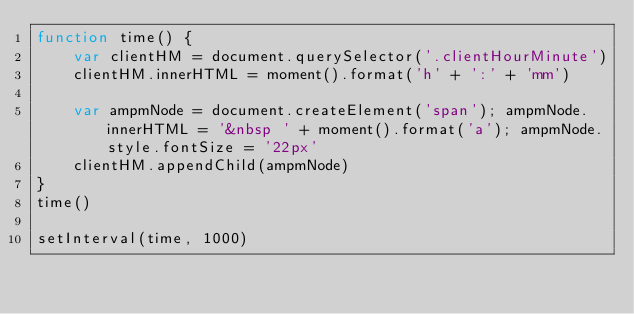<code> <loc_0><loc_0><loc_500><loc_500><_JavaScript_>function time() {
    var clientHM = document.querySelector('.clientHourMinute')
    clientHM.innerHTML = moment().format('h' + ':' + 'mm') 

    var ampmNode = document.createElement('span'); ampmNode.innerHTML = '&nbsp ' + moment().format('a'); ampmNode.style.fontSize = '22px'
    clientHM.appendChild(ampmNode) 
}
time()

setInterval(time, 1000)</code> 